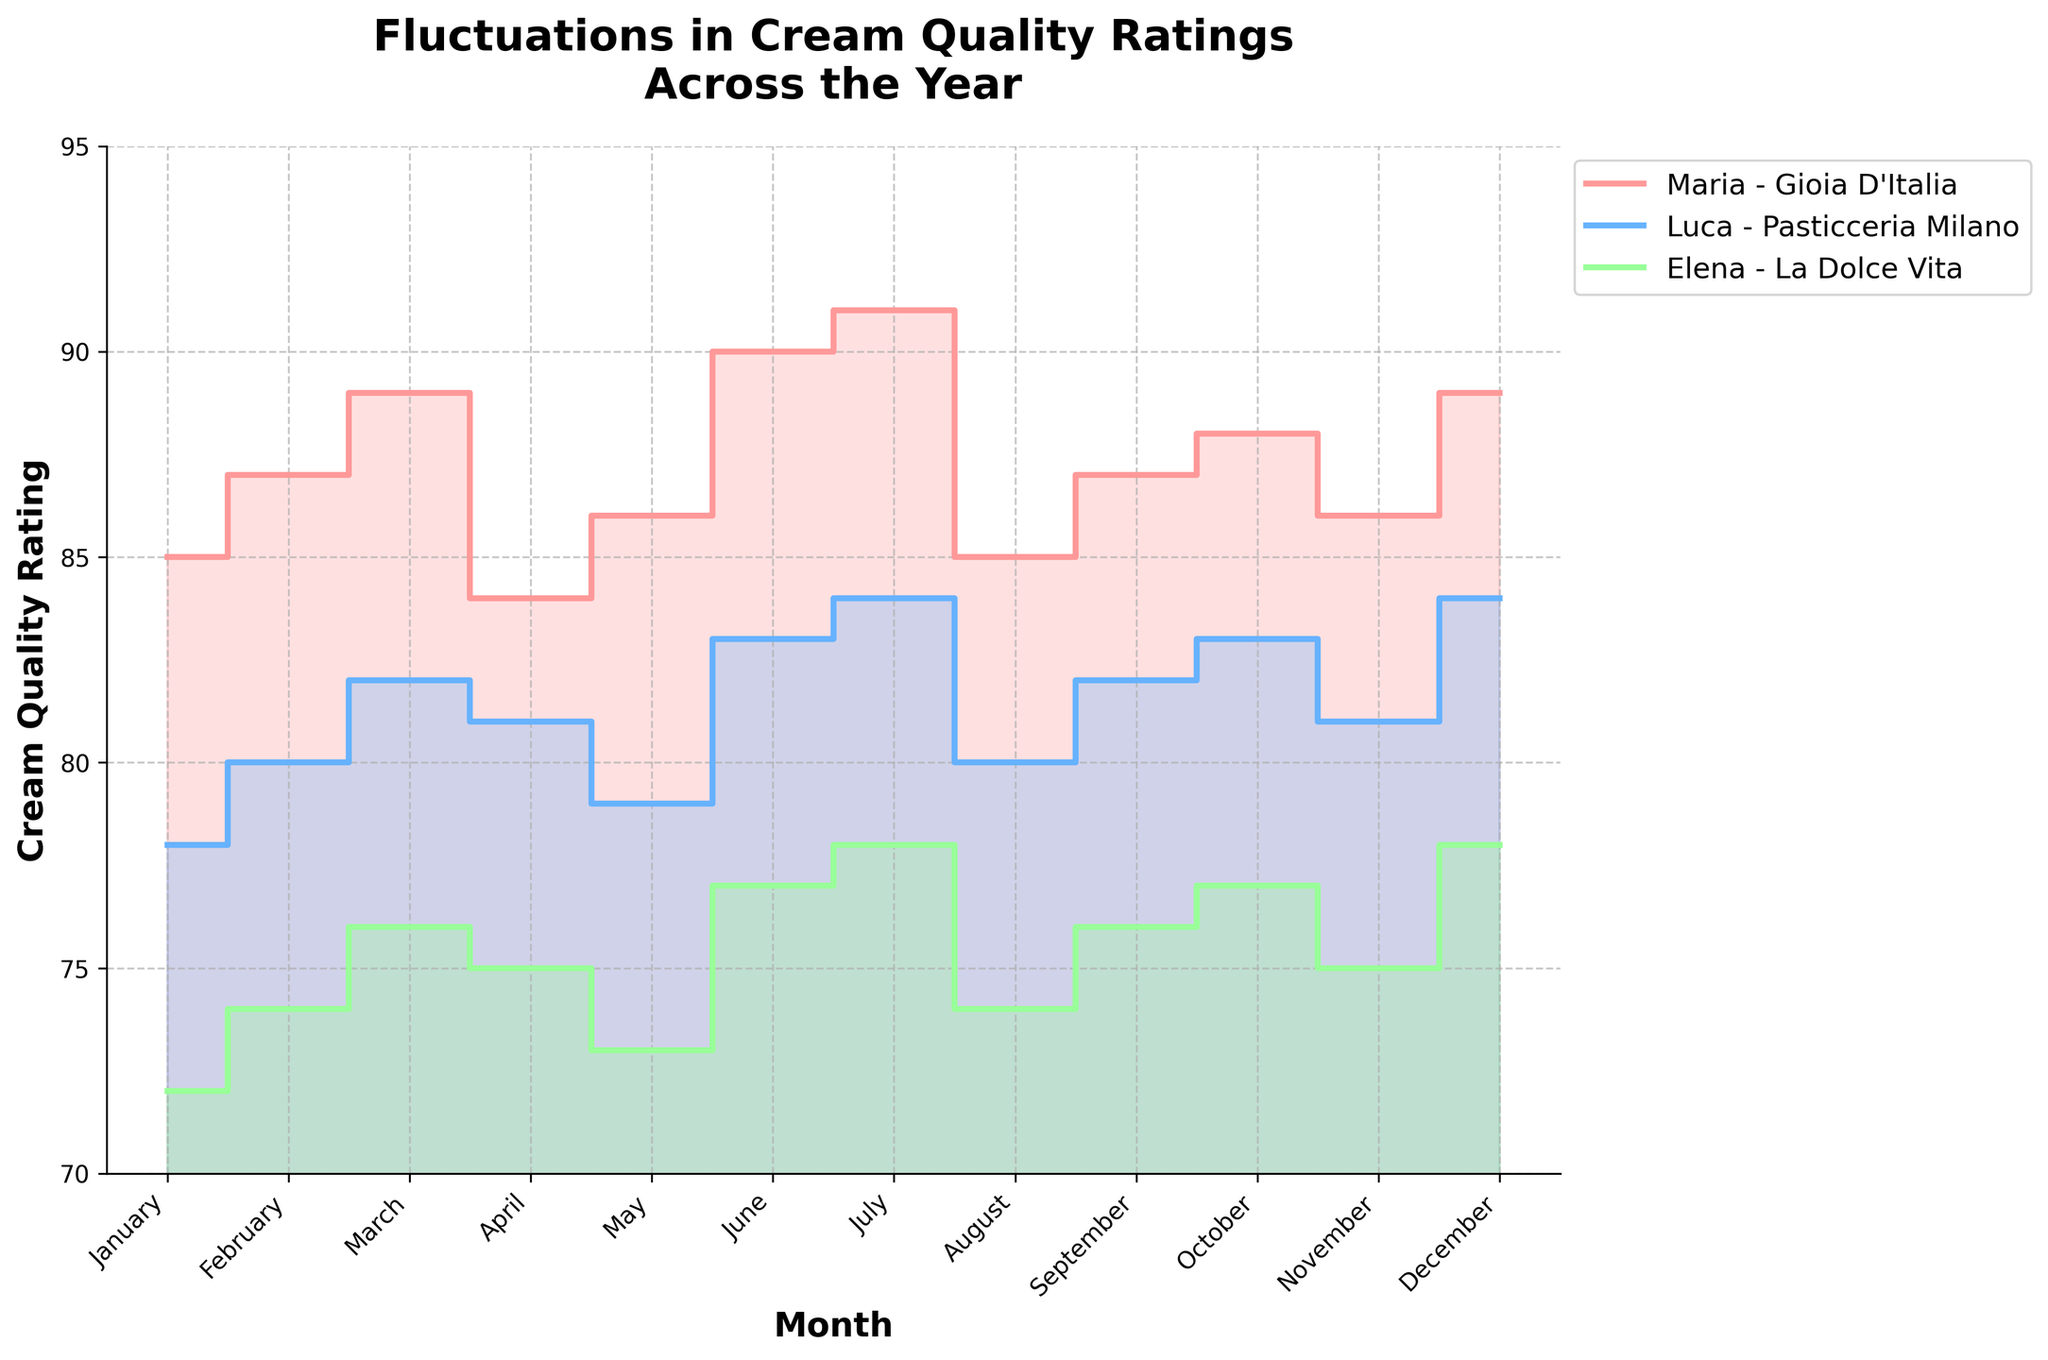What is the title of the chart? The title appears at the top of the chart and provides a summary of the content displayed. Here, it reads "Fluctuations in Cream Quality Ratings Across the Year."
Answer: Fluctuations in Cream Quality Ratings Across the Year Which chef had the highest cream quality rating in December? By observing the values on the y-axis and the corresponding lines for each chef in December, we can identify the highest rating. Maria from Gioia D'Italia rated 89, which is the highest in December.
Answer: Maria In which month did Luca (Pasticceria Milano) have the lowest cream quality rating? Observing the step area representing Luca's ratings, we note that the lowest point occurs in January, with a rating of 78.
Answer: January Compare the cream quality ratings of Maria (Gioia D'Italia) and Elena (La Dolce Vita) in July. Which chef had a higher rating and by how much? In July, Maria's rating is 91 and Elena's is 78. By subtracting Elena's rating from Maria's, we get 91 - 78 = 13. Maria had a higher rating by 13 points.
Answer: Maria by 13 points Which chef's ratings had the largest fluctuation throughout the year? Fluctuation can be measured by the range, which is the difference between the maximum and minimum values. Maria’s range is 91 - 84 = 7, Luca’s range is 84 - 78 = 6, and Elena’s range is 78 - 72 = 6. The largest fluctuation is Maria’s with a range of 7.
Answer: Maria On average, which chef had the highest cream quality ratings over the year? Calculate the average rating for each chef: 
Maria: (85+87+89+84+86+90+91+85+87+88+86+89)/12 = 87.25,
Luca: (78+80+82+81+79+83+84+80+82+83+81+84)/12 = 81.25,
Elena: (72+74+76+75+73+77+78+74+76+77+75+78)/12 = 75.5.
Thus, Maria had the highest average rating.
Answer: Maria What is the trend of Elena (La Dolce Vita) cream quality ratings from April to July? Observing the step area for Elena from April to July, the ratings are 75, 73, 77, and 78 respectively. The trend shows an overall increasing pattern after a slight drop in May.
Answer: Increasing In which months did all chefs have the same trend in cream quality ratings (either all increasing or all decreasing)? By checking individual ratings month by month:
- February: Maria, Luca, and Elena all increased from January.
- March: Maria, Luca, and Elena all increased from February.
No other months show the same trend for everyone.
Answer: February and March What is the overall trend in Maria's (Gioia D'Italia) cream quality ratings throughout the year? Tracking Maria's ratings from January to December shows several fluctuations without a consistent trend: 85, 87, 89, 84, 86, 90, 91, 85, 87, 88, 86, and 89. There were both increases and decreases throughout the year.
Answer: Fluctuating 